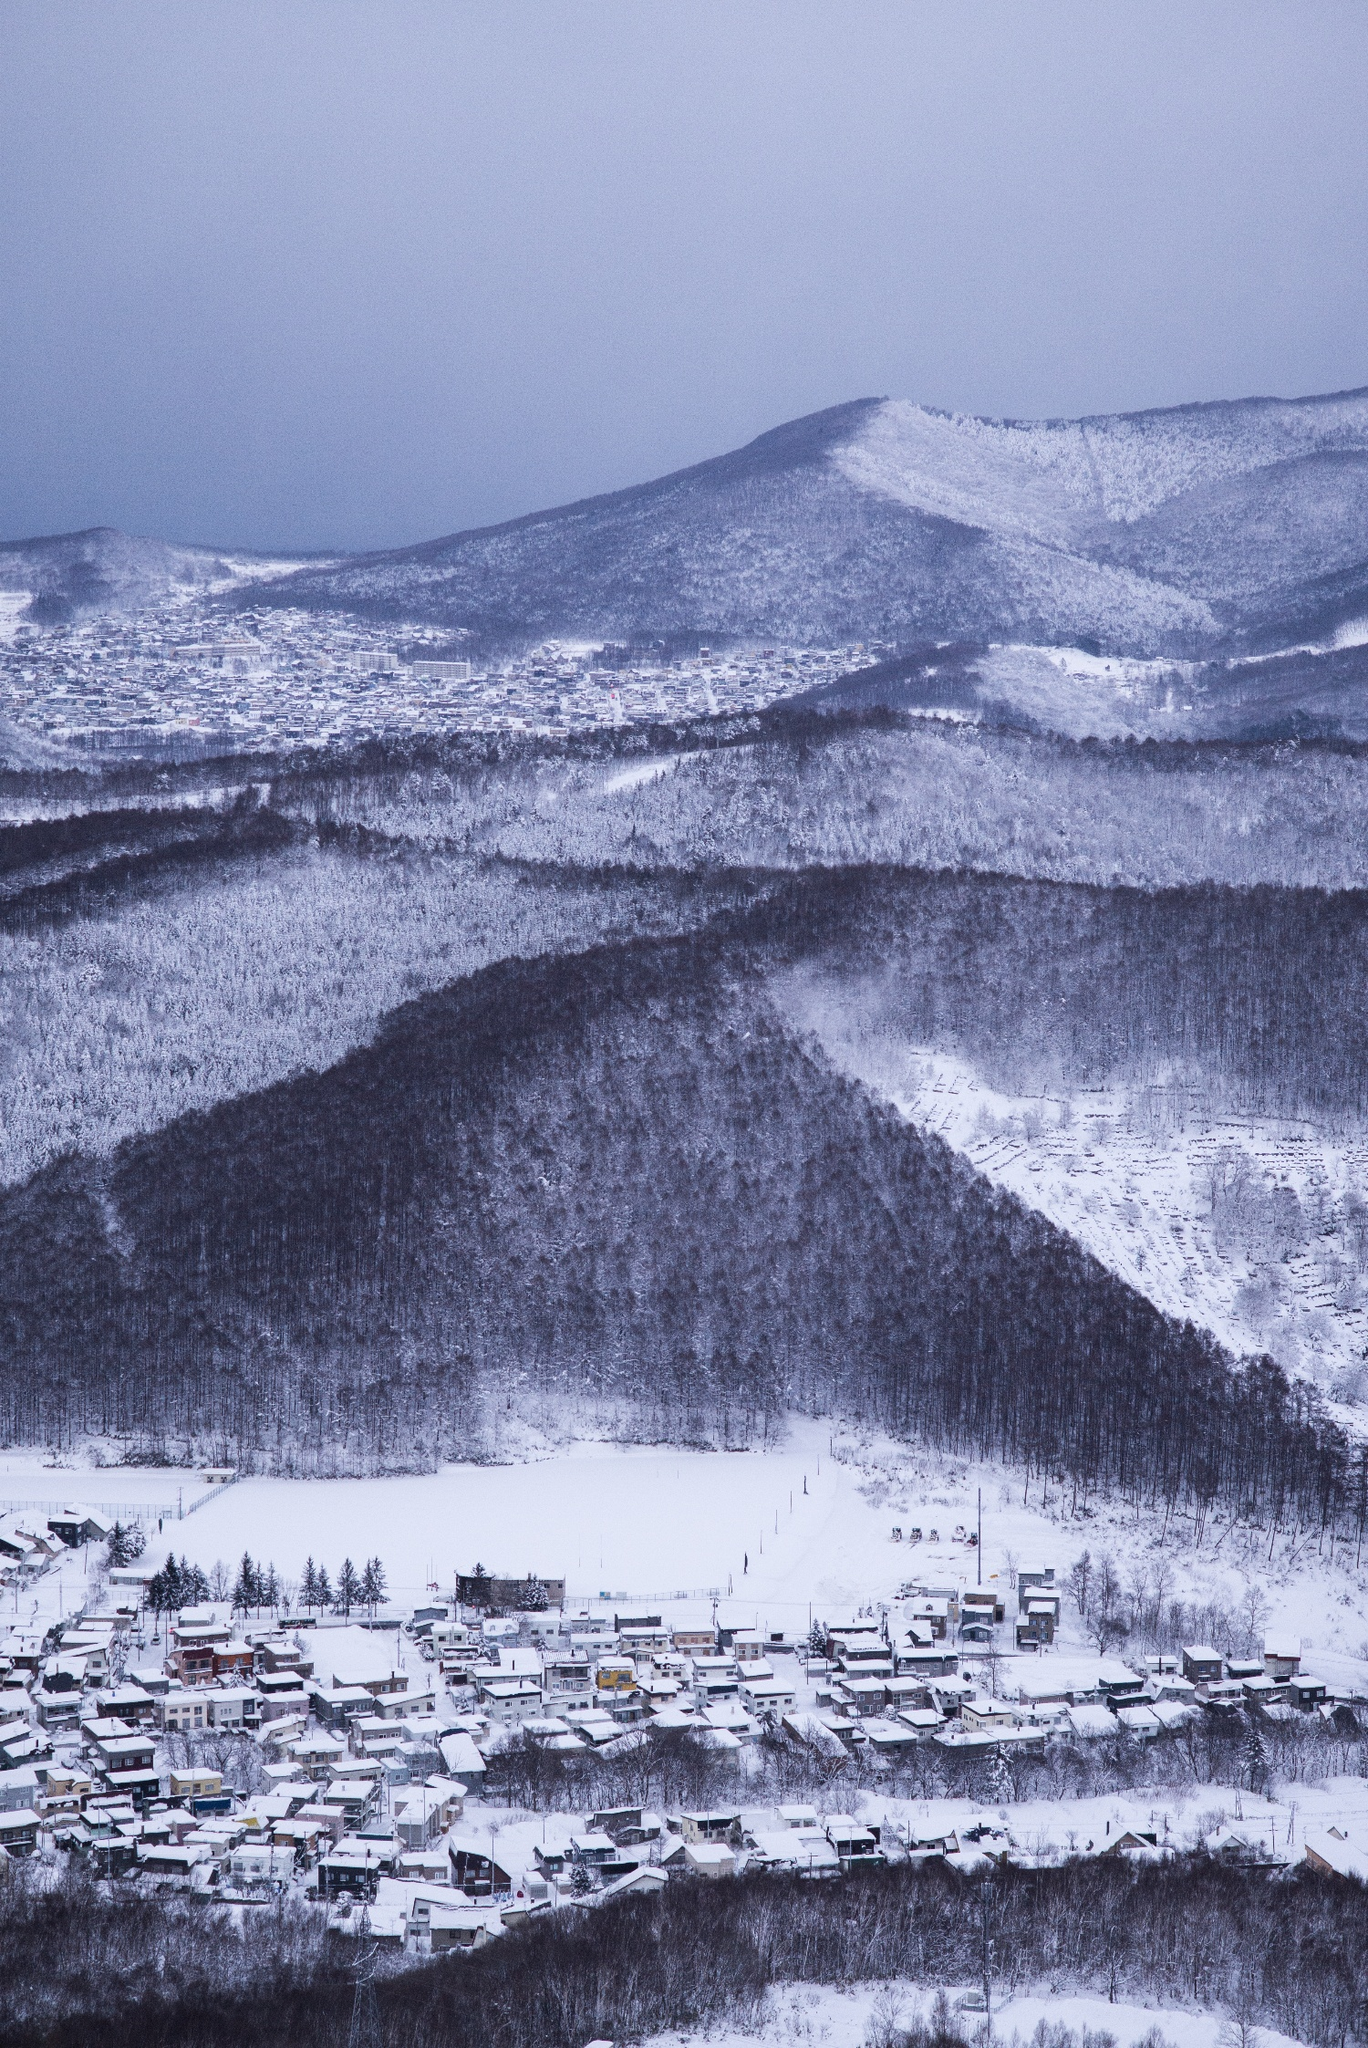Write a detailed description of the given image. The image provides a stunning, almost ethereal view of a mountain landscape under a blanket of snow. From a high vantage point, we see a quaint town cradled in a valley, surrounded by towering mountains whose peaks disappear into a somber gray sky. The snowy cover transforms the area into a monochromatic scene punctuated by the occasional greys of bare trees and the varying shades of the rooftops, hinting at a serene isolation. There's a palpable quietness to the scene, suggesting the slow, relaxed pace of life in this secluded spot, possibly disrupted only by the soft sounds of nature and the occasional hum of a distant snow vehicle. This image not only captures the beauty of a harsh, wintery landscape but also subtly invokes the resilience of life that persists within it. 